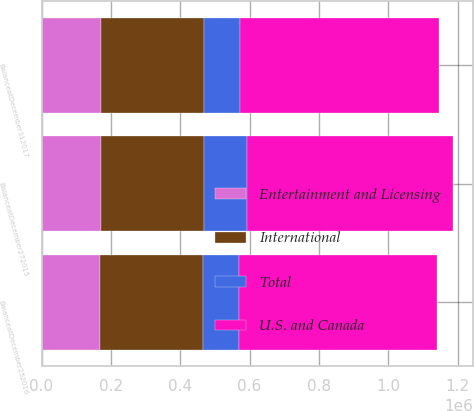<chart> <loc_0><loc_0><loc_500><loc_500><stacked_bar_chart><ecel><fcel>BalanceatDecember252016<fcel>BalanceatDecember312017<fcel>BalanceatDecember272015<nl><fcel>International<fcel>296978<fcel>296978<fcel>296978<nl><fcel>Entertainment and Licensing<fcel>169833<fcel>170699<fcel>170110<nl><fcel>Total<fcel>103744<fcel>105386<fcel>125607<nl><fcel>U.S. and Canada<fcel>570555<fcel>573063<fcel>592695<nl></chart> 